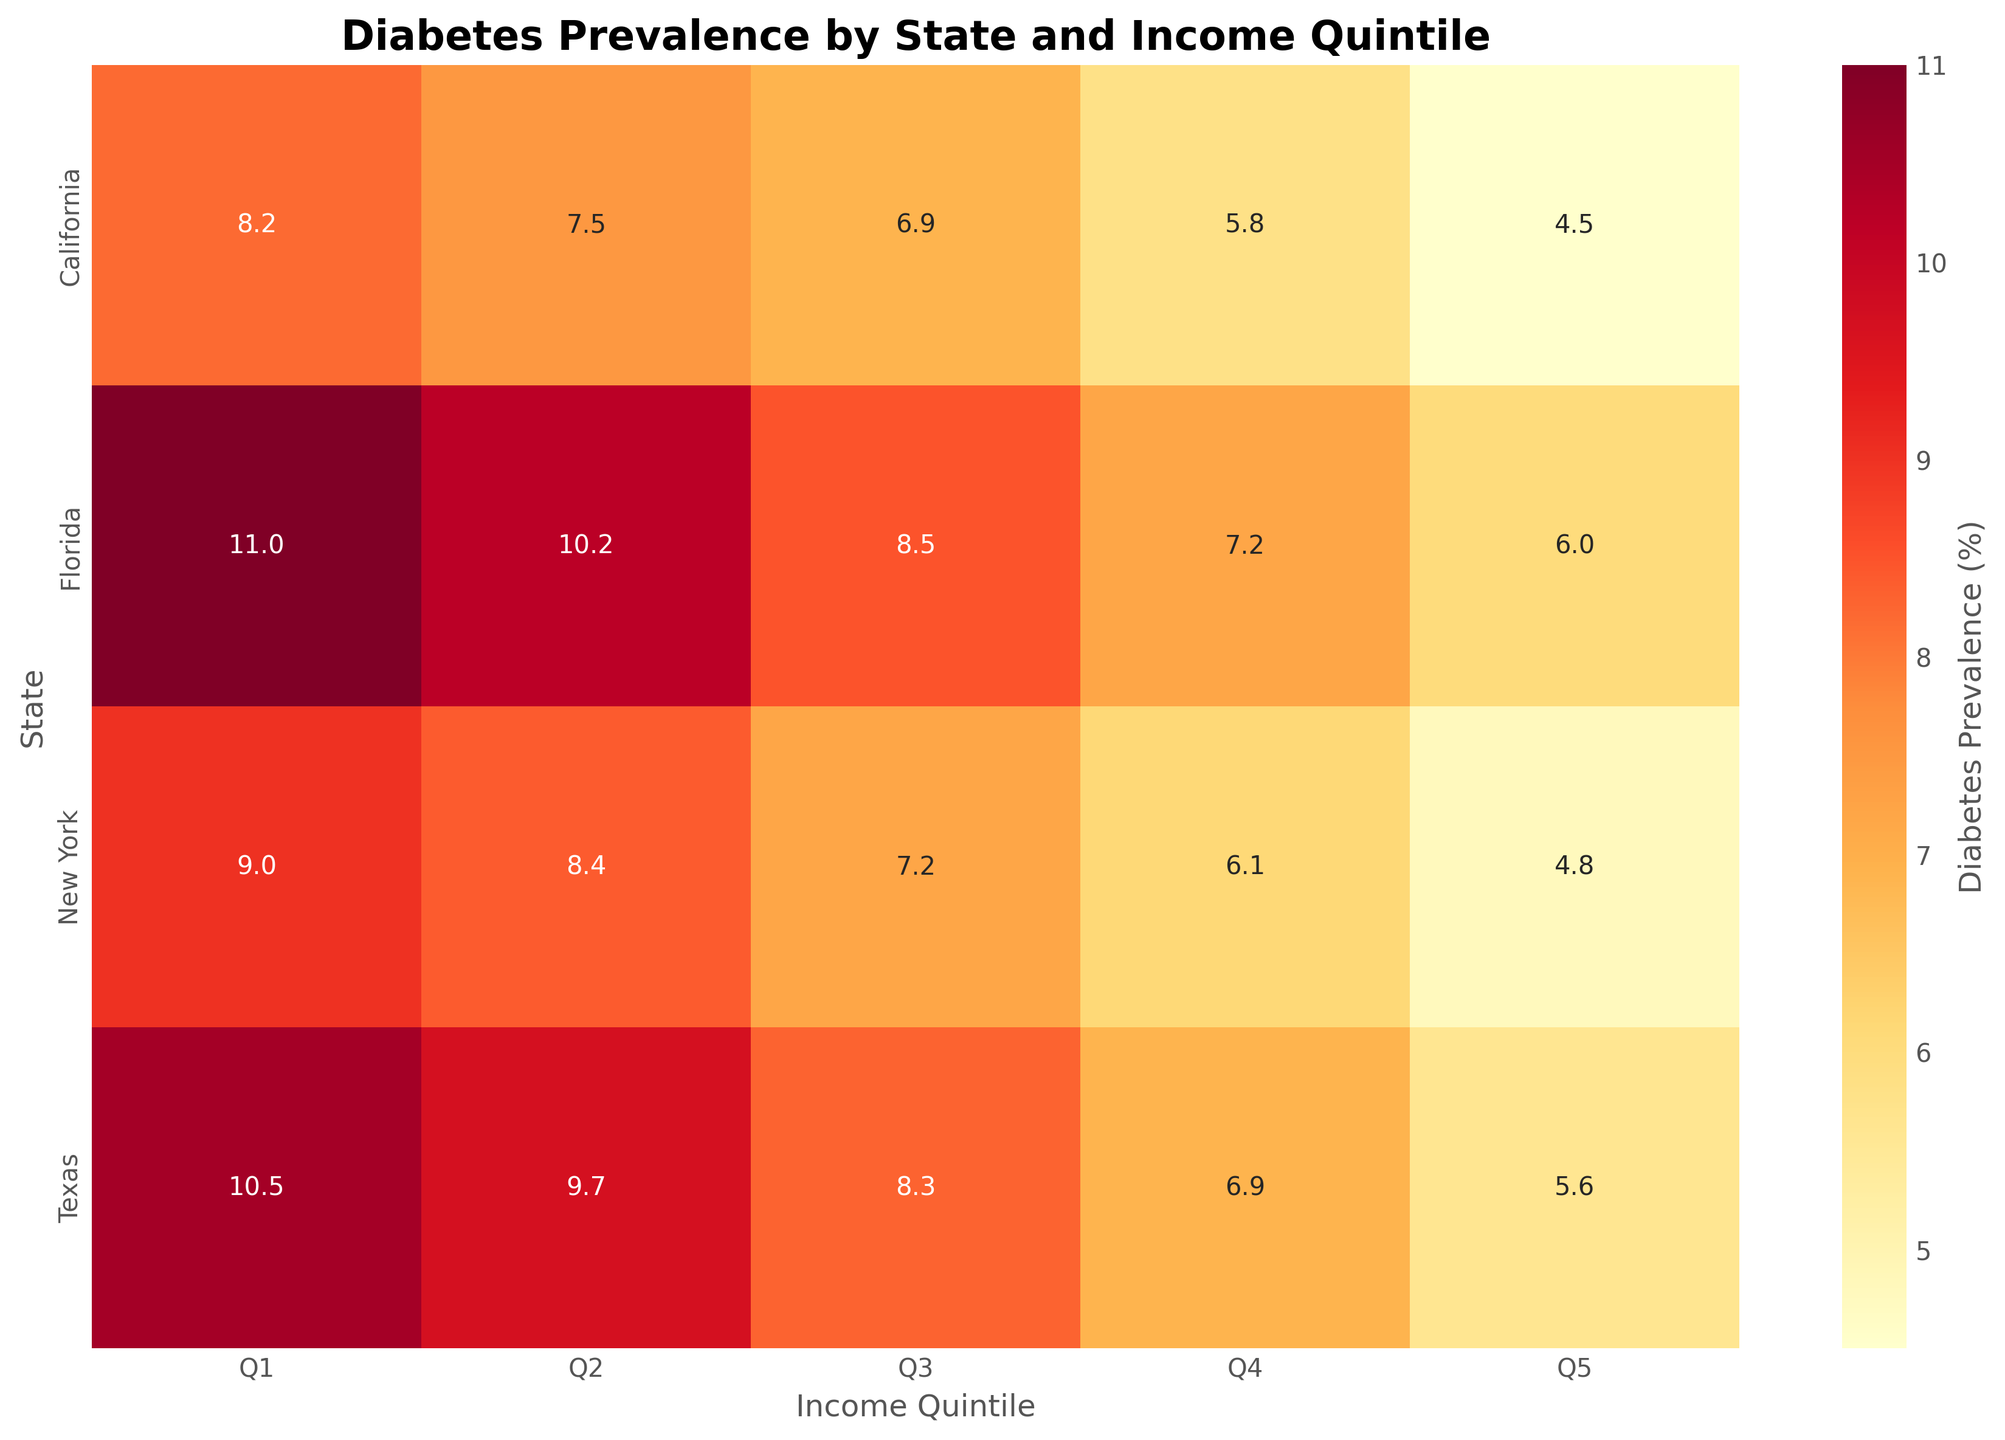What's the title of the figure? The title of the figure can be seen at the top and it's typically written in a larger, bold font for emphasis.
Answer: 'Diabetes Prevalence by State and Income Quintile' Which state has the highest diabetes prevalence in the lowest income quintile (Q1)? The figure shows the diabetes prevalence for each state in Q1, visible as the top row in the heatmap. The highest value appears in Florida.
Answer: Florida What is the difference in diabetes prevalence between income quintile Q1 and Q5 in California? Identify the values in the Q1 and Q5 columns for California state (first row). Q1 is 8.2% and Q5 is 4.5%. The difference is 8.2% - 4.5%.
Answer: 3.7% Which state shows the lowest diabetes prevalence in income quintile Q2? Looking at the values in the Q2 column for each state, identify the lowest value, which belongs to California.
Answer: California How does the diabetes prevalence change from Q1 to Q5 generally in all states? Examine the values in each row from Q1 to Q5. You will observe a general decreasing trend in each state when moving from Q1 (lowest income) to Q5 (highest income).
Answer: Decreases What is the average diabetes prevalence for income quintile Q3 across all the states? Sum the diabetes prevalence percentages for Q3 across all states (6.9 + 8.3 + 7.2 + 8.5) and divide by the number of states (4). Thus, (6.9 + 8.3 + 7.2 + 8.5)/4.
Answer: 7.725% Which state has the least variation in diabetes prevalence across income quintiles? Calculate the differences between Q1 and Q5 for each state and identify the one with the smallest difference: California (8.2%-4.5%=3.7%), Texas (10.5%-5.6%=4.9%), New York (9.0%-4.8%=4.2%), and Florida (11.0%-6.0%=5.0%). California has the least variation.
Answer: California What is the most common trend observed in the heatmap? By glancing through the cells from Q1 to Q5 for each state, the consistent pattern is that diabetes prevalence decreases as income quintile increases.
Answer: Decreasing trend from Q1 to Q5 